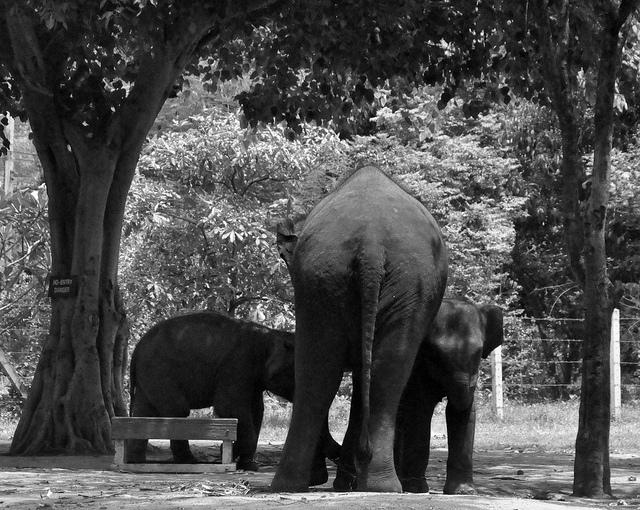What are the Elephants standing on? ground 